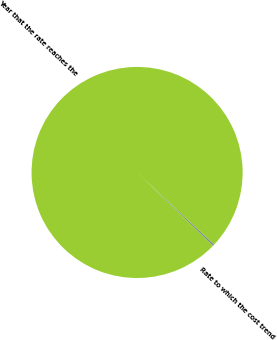<chart> <loc_0><loc_0><loc_500><loc_500><pie_chart><fcel>Rate to which the cost trend<fcel>Year that the rate reaches the<nl><fcel>0.25%<fcel>99.75%<nl></chart> 